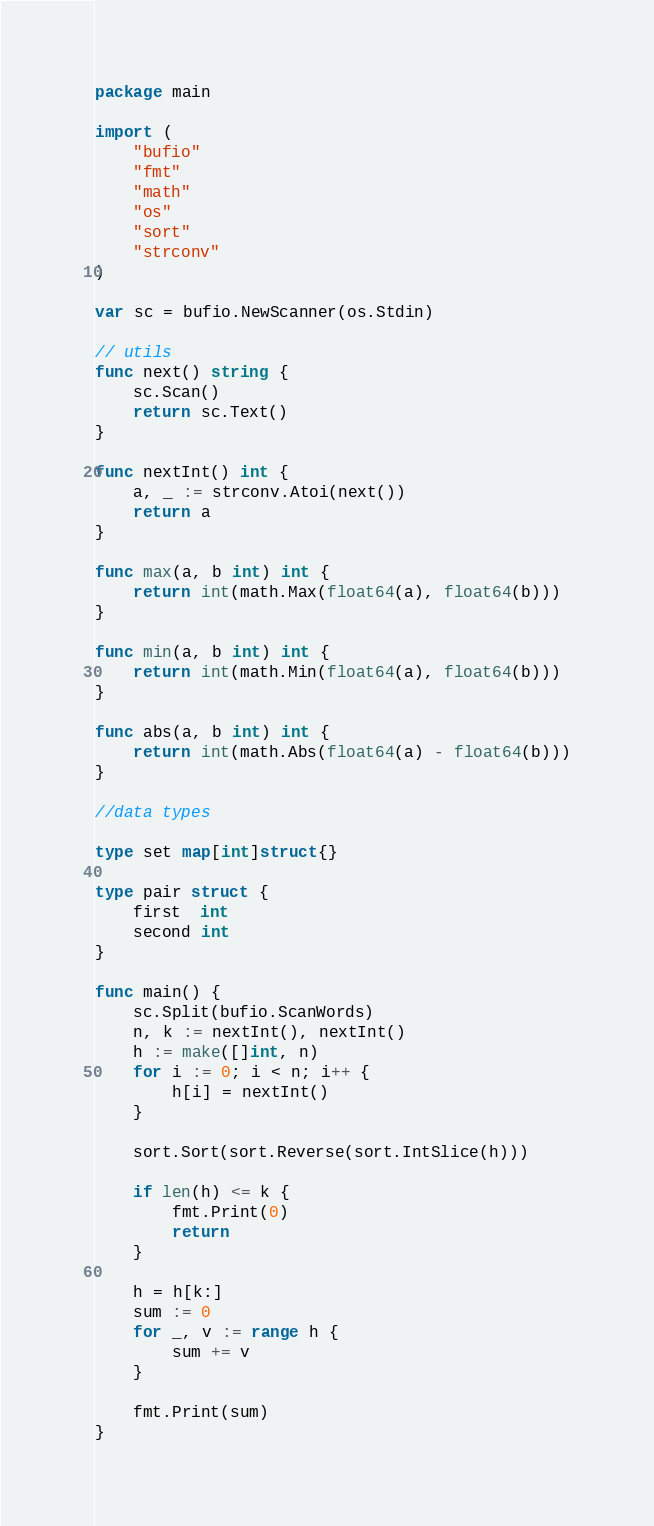<code> <loc_0><loc_0><loc_500><loc_500><_Go_>package main

import (
	"bufio"
	"fmt"
	"math"
	"os"
	"sort"
	"strconv"
)

var sc = bufio.NewScanner(os.Stdin)

// utils
func next() string {
	sc.Scan()
	return sc.Text()
}

func nextInt() int {
	a, _ := strconv.Atoi(next())
	return a
}

func max(a, b int) int {
	return int(math.Max(float64(a), float64(b)))
}

func min(a, b int) int {
	return int(math.Min(float64(a), float64(b)))
}

func abs(a, b int) int {
	return int(math.Abs(float64(a) - float64(b)))
}

//data types

type set map[int]struct{}

type pair struct {
	first  int
	second int
}

func main() {
	sc.Split(bufio.ScanWords)
	n, k := nextInt(), nextInt()
	h := make([]int, n)
	for i := 0; i < n; i++ {
		h[i] = nextInt()
	}

	sort.Sort(sort.Reverse(sort.IntSlice(h)))

	if len(h) <= k {
		fmt.Print(0)
		return
	}

	h = h[k:]
	sum := 0
	for _, v := range h {
		sum += v
	}

	fmt.Print(sum)
}
</code> 